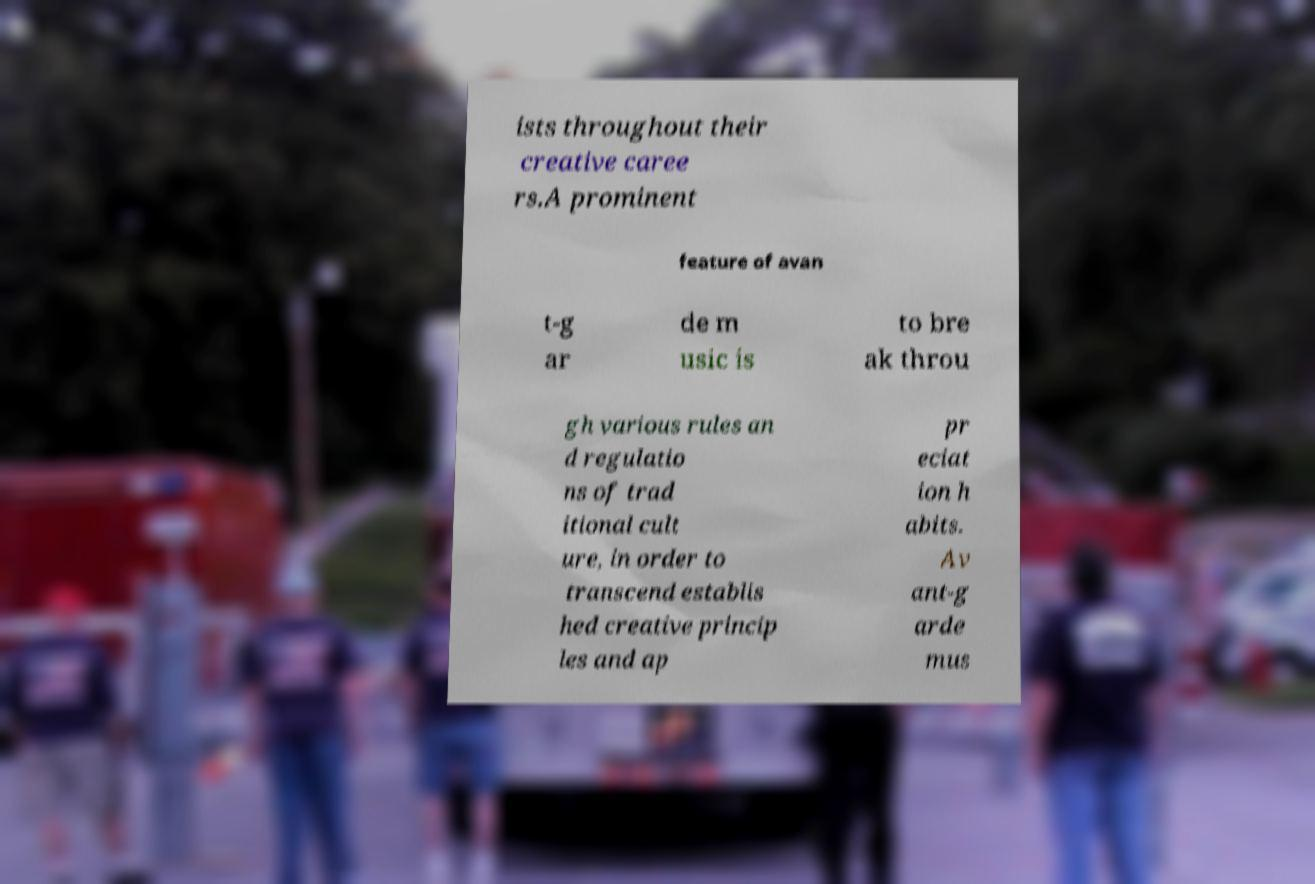Can you accurately transcribe the text from the provided image for me? ists throughout their creative caree rs.A prominent feature of avan t-g ar de m usic is to bre ak throu gh various rules an d regulatio ns of trad itional cult ure, in order to transcend establis hed creative princip les and ap pr eciat ion h abits. Av ant-g arde mus 